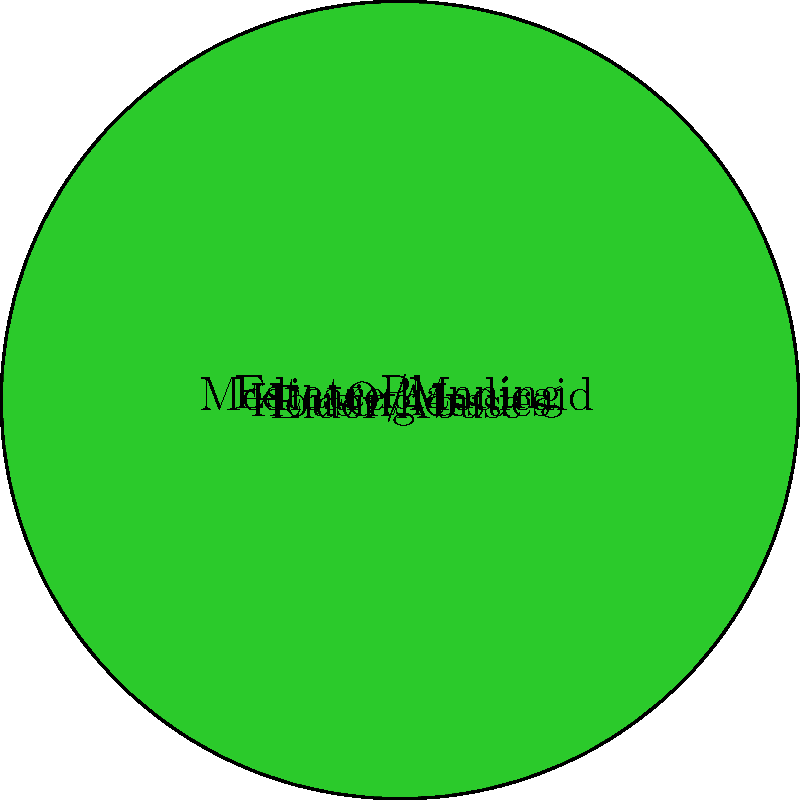In the pie chart representing different types of legal services provided to seniors, what is the measure of the central angle for the "Medicare/Medicaid" category? To find the measure of the central angle for the "Medicare/Medicaid" category, we need to follow these steps:

1. Identify the total sum of all values:
   $30 + 45 + 60 + 75 + 150 = 360$

2. Calculate the fraction of the total that "Medicare/Medicaid" represents:
   $\frac{45}{360} = \frac{1}{8}$

3. Convert this fraction to degrees:
   $\frac{1}{8} \times 360° = 45°$

Therefore, the measure of the central angle for the "Medicare/Medicaid" category is 45°.
Answer: 45° 